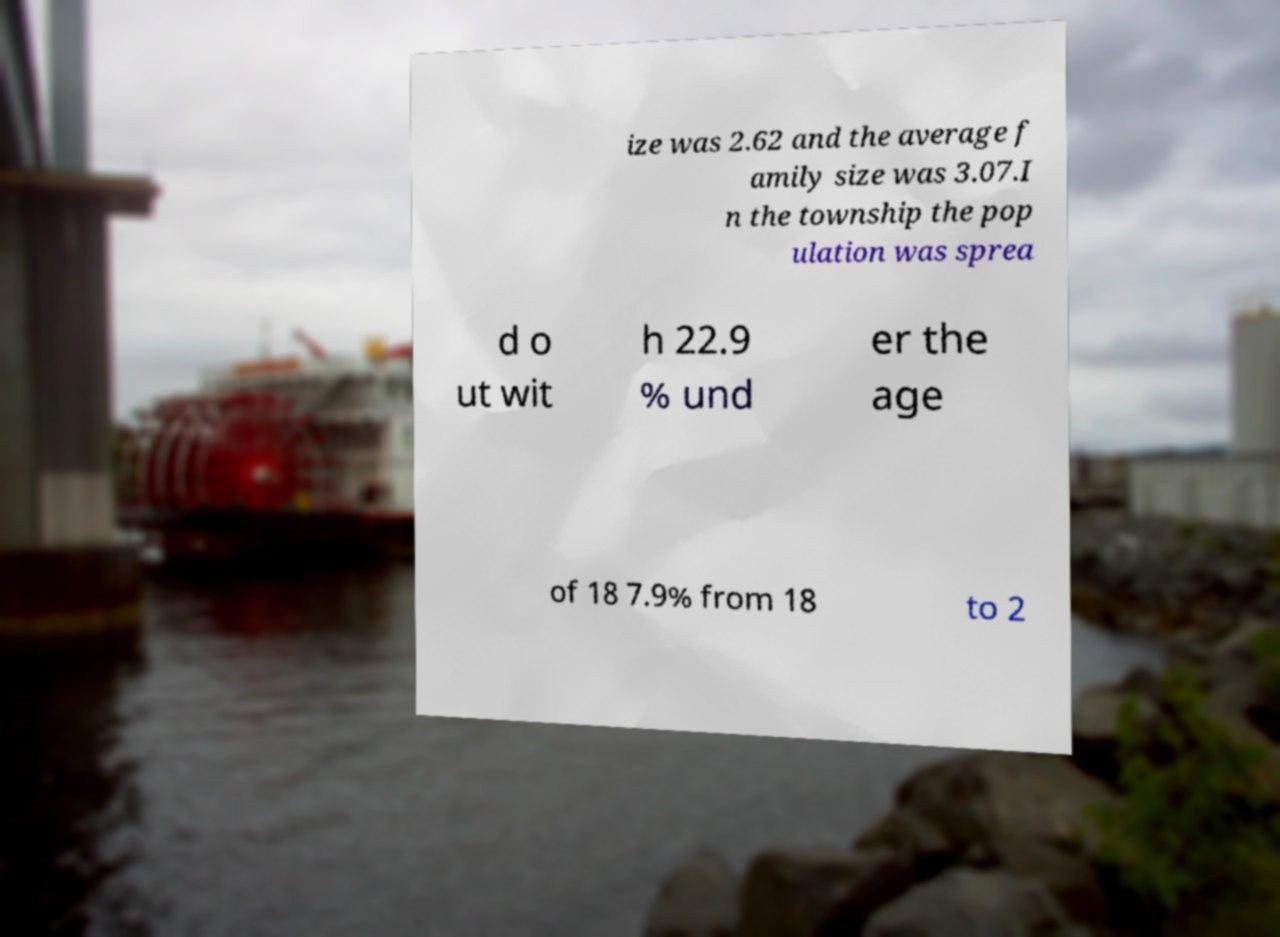What messages or text are displayed in this image? I need them in a readable, typed format. ize was 2.62 and the average f amily size was 3.07.I n the township the pop ulation was sprea d o ut wit h 22.9 % und er the age of 18 7.9% from 18 to 2 